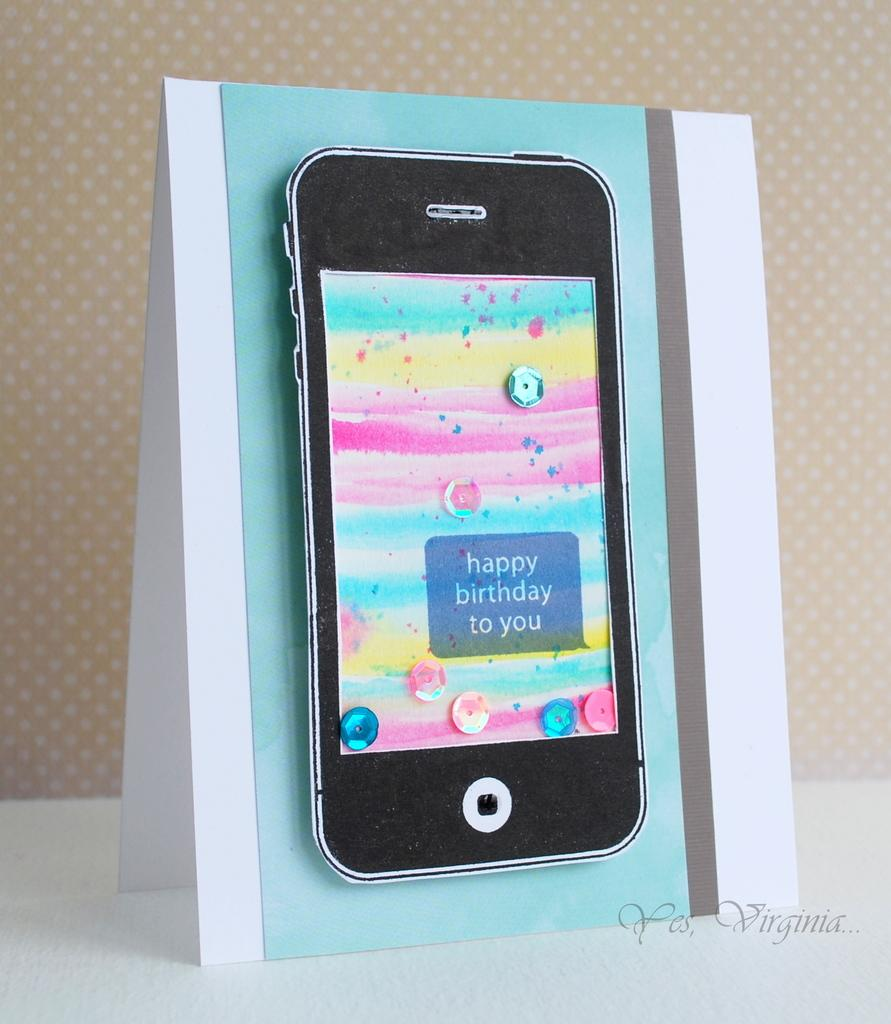<image>
Give a short and clear explanation of the subsequent image. A greeting card with a smartphone on it that says happy birthday to you 